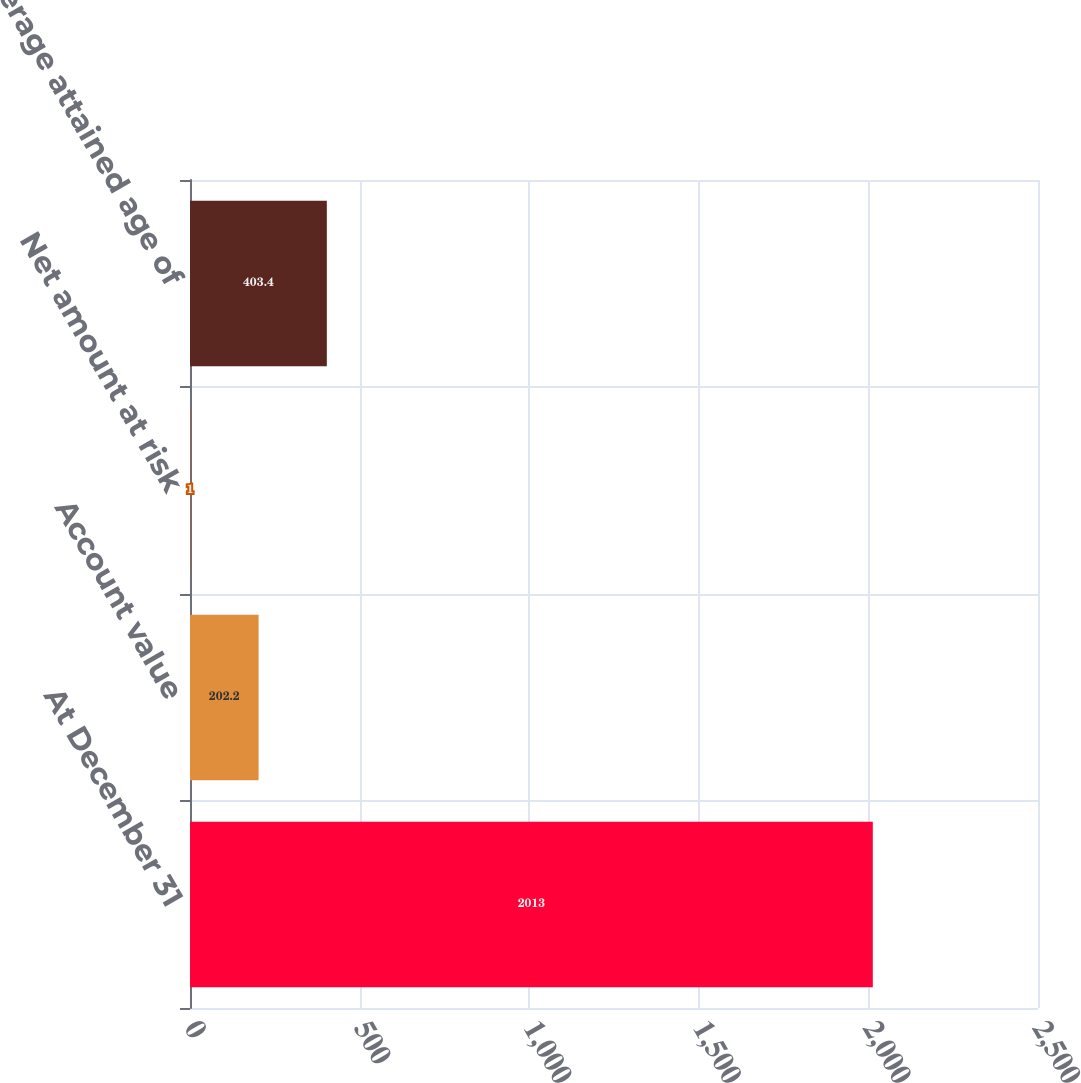<chart> <loc_0><loc_0><loc_500><loc_500><bar_chart><fcel>At December 31<fcel>Account value<fcel>Net amount at risk<fcel>Average attained age of<nl><fcel>2013<fcel>202.2<fcel>1<fcel>403.4<nl></chart> 